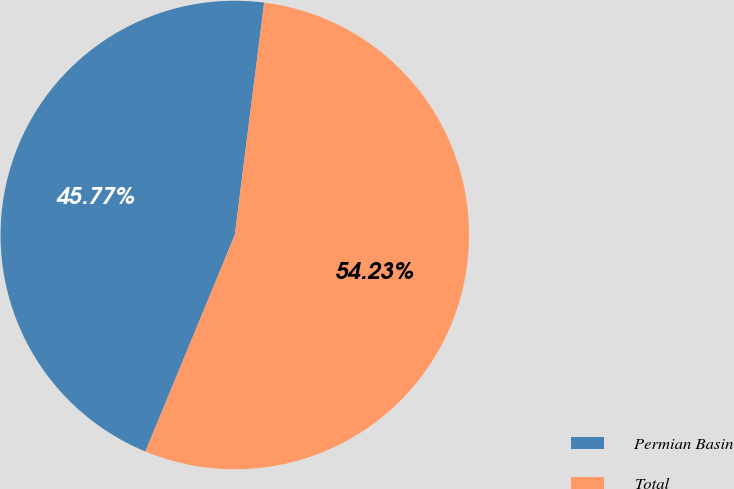Convert chart to OTSL. <chart><loc_0><loc_0><loc_500><loc_500><pie_chart><fcel>Permian Basin<fcel>Total<nl><fcel>45.77%<fcel>54.23%<nl></chart> 